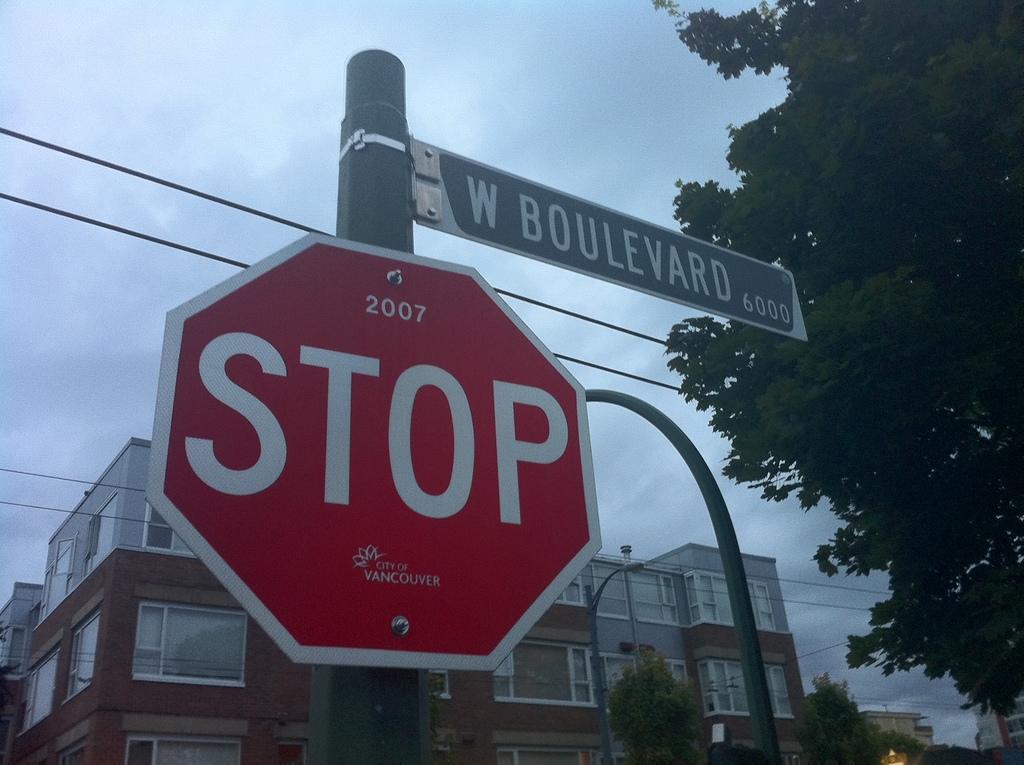What is the street name?
Ensure brevity in your answer.  W boulevard. What is the year on the stop sign?
Offer a terse response. 2007. 